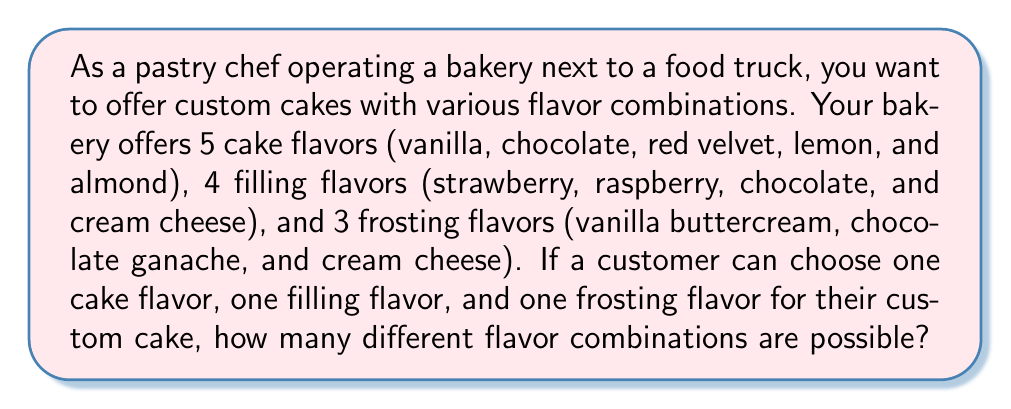Solve this math problem. To solve this problem, we need to use the multiplication principle of counting. This principle states that if we have $m$ ways of doing one thing, $n$ ways of doing another thing, and $p$ ways of doing a third thing, then there are $m \times n \times p$ ways of doing all three things.

In this case, we have:
1. 5 cake flavors
2. 4 filling flavors
3. 3 frosting flavors

Each choice is independent of the others, meaning the selection of one does not affect the options for the others.

Therefore, we can calculate the total number of possible combinations as follows:

$$ \text{Total combinations} = \text{Cake flavors} \times \text{Filling flavors} \times \text{Frosting flavors} $$

$$ \text{Total combinations} = 5 \times 4 \times 3 $$

$$ \text{Total combinations} = 60 $$

This means that customers can create 60 unique flavor combinations for their custom cakes.
Answer: 60 possible flavor combinations 